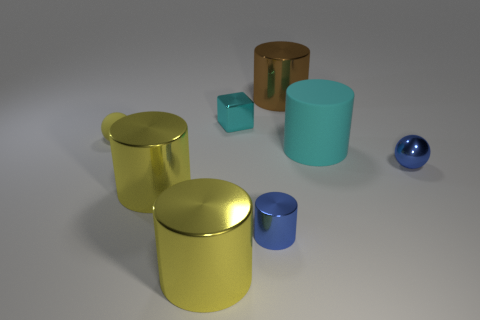Subtract all blue spheres. How many yellow cylinders are left? 2 Add 1 brown metal cylinders. How many objects exist? 9 Subtract 2 cylinders. How many cylinders are left? 3 Subtract all blue cylinders. How many cylinders are left? 4 Subtract all blue metal cylinders. How many cylinders are left? 4 Subtract all cubes. How many objects are left? 7 Subtract all cyan cylinders. Subtract all green cubes. How many cylinders are left? 4 Add 7 tiny cyan cubes. How many tiny cyan cubes exist? 8 Subtract 0 purple cylinders. How many objects are left? 8 Subtract all yellow metallic things. Subtract all tiny cyan shiny blocks. How many objects are left? 5 